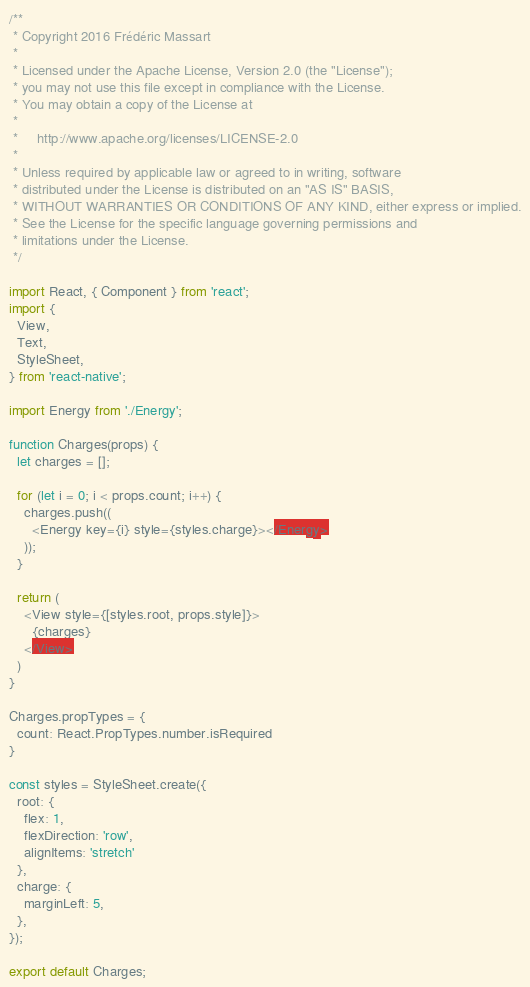Convert code to text. <code><loc_0><loc_0><loc_500><loc_500><_JavaScript_>/**
 * Copyright 2016 Frédéric Massart
 *
 * Licensed under the Apache License, Version 2.0 (the "License");
 * you may not use this file except in compliance with the License.
 * You may obtain a copy of the License at
 *
 *     http://www.apache.org/licenses/LICENSE-2.0
 *
 * Unless required by applicable law or agreed to in writing, software
 * distributed under the License is distributed on an "AS IS" BASIS,
 * WITHOUT WARRANTIES OR CONDITIONS OF ANY KIND, either express or implied.
 * See the License for the specific language governing permissions and
 * limitations under the License.
 */

import React, { Component } from 'react';
import {
  View,
  Text,
  StyleSheet,
} from 'react-native';

import Energy from './Energy';

function Charges(props) {
  let charges = [];

  for (let i = 0; i < props.count; i++) {
    charges.push((
      <Energy key={i} style={styles.charge}></Energy>
    ));
  }

  return (
    <View style={[styles.root, props.style]}>
      {charges}
    </View>
  )
}

Charges.propTypes = {
  count: React.PropTypes.number.isRequired
}

const styles = StyleSheet.create({
  root: {
    flex: 1,
    flexDirection: 'row',
    alignItems: 'stretch'
  },
  charge: {
    marginLeft: 5,
  },
});

export default Charges;
</code> 